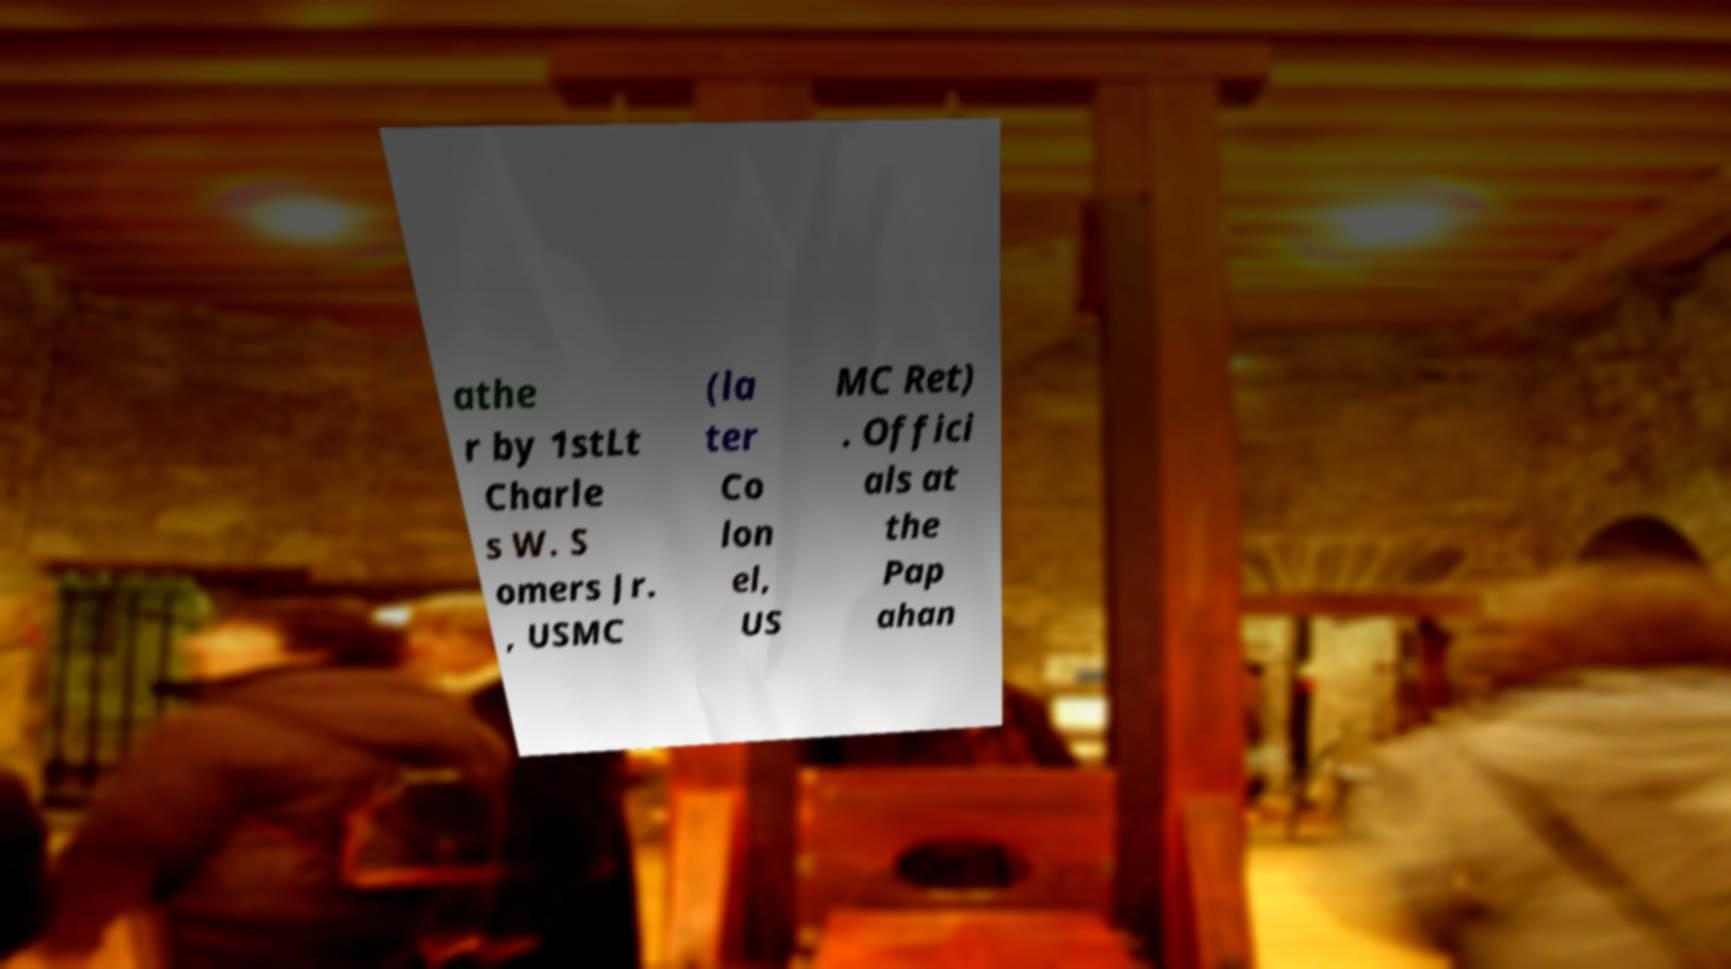For documentation purposes, I need the text within this image transcribed. Could you provide that? athe r by 1stLt Charle s W. S omers Jr. , USMC (la ter Co lon el, US MC Ret) . Offici als at the Pap ahan 